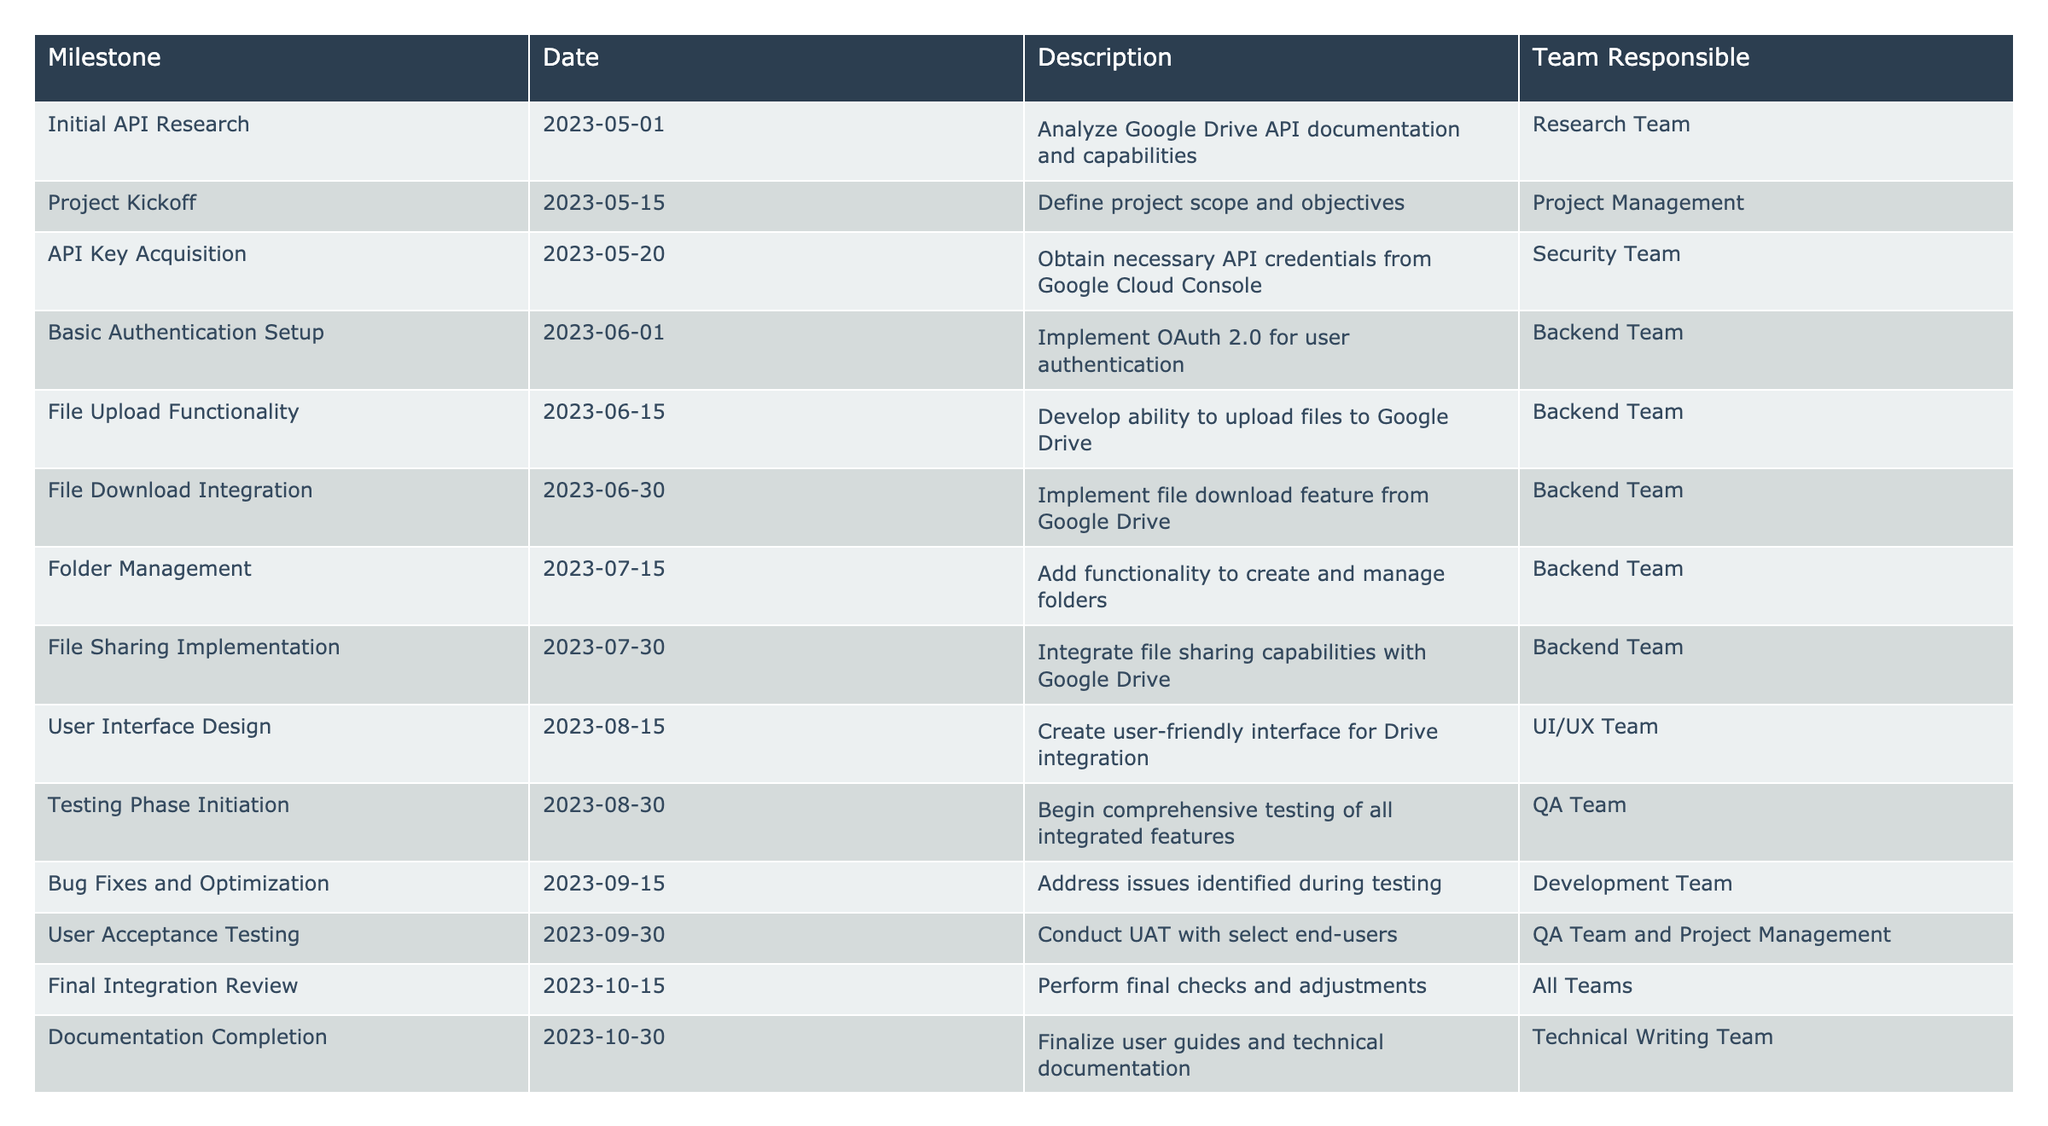What is the date for the Project Kickoff milestone? The Project Kickoff milestone is listed with the date 2023-05-15 in the table.
Answer: 2023-05-15 Who is responsible for the User Interface Design? The responsibility for User Interface Design is assigned to the UI/UX Team as per the table.
Answer: UI/UX Team How many days are there between the API Key Acquisition and the File Upload Functionality? The API Key Acquisition is on 2023-05-20 and the File Upload Functionality is on 2023-06-15. Counting the days, there are 26 days between these two milestones.
Answer: 26 days Did the Backend Team work on the File Download Integration? According to the table, the Backend Team is responsible for the File Download Integration milestone. Therefore, the answer is yes.
Answer: Yes What is the total number of milestones scheduled to be completed by the end of October? There are 12 milestones listed up until the end of October, counting from the Initial API Research to Documentation Completion.
Answer: 12 How much time is allocated for testing activities from Testing Phase Initiation to the Final Integration Review? Testing Phase Initiation is on 2023-08-30 and Final Integration Review is on 2023-10-15, which gives a total of 46 days allocated for testing activities.
Answer: 46 days Which team is responsible for addressing bugs identified during testing? The table indicates that the Development Team is responsible for Bug Fixes and Optimization as part of the integration process.
Answer: Development Team Which milestone is scheduled closest to the Launch date? The Go-Live Preparation milestone on 2023-11-15 is the closest milestone before the Launch on 2023-11-30, making it the nearest milestone prior to launch.
Answer: Go-Live Preparation What is the duration between the File Sharing Implementation and the User Acceptance Testing? The File Sharing Implementation is on 2023-07-30 and the User Acceptance Testing begins on 2023-09-30. This gives a duration of 61 days between these two events.
Answer: 61 days 